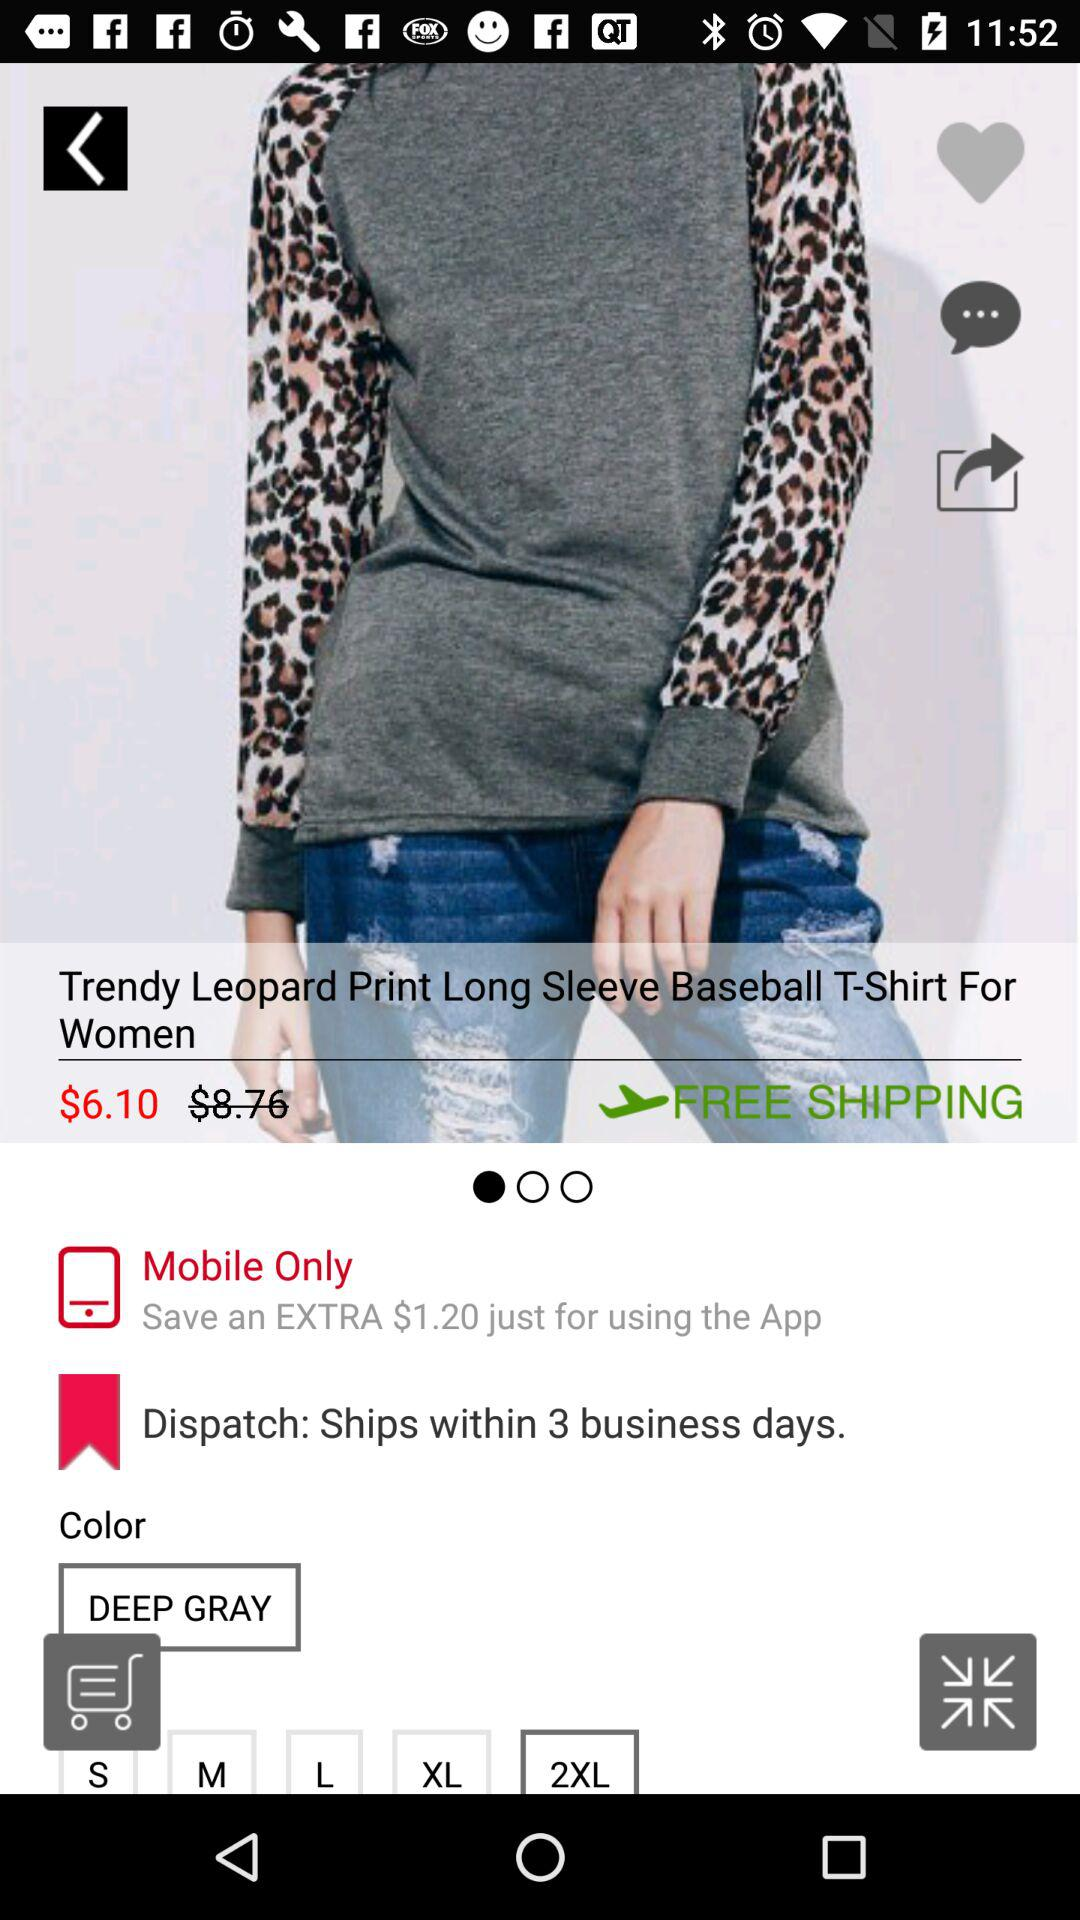Is shipping free or paid?
Answer the question using a single word or phrase. Shipping is free. 